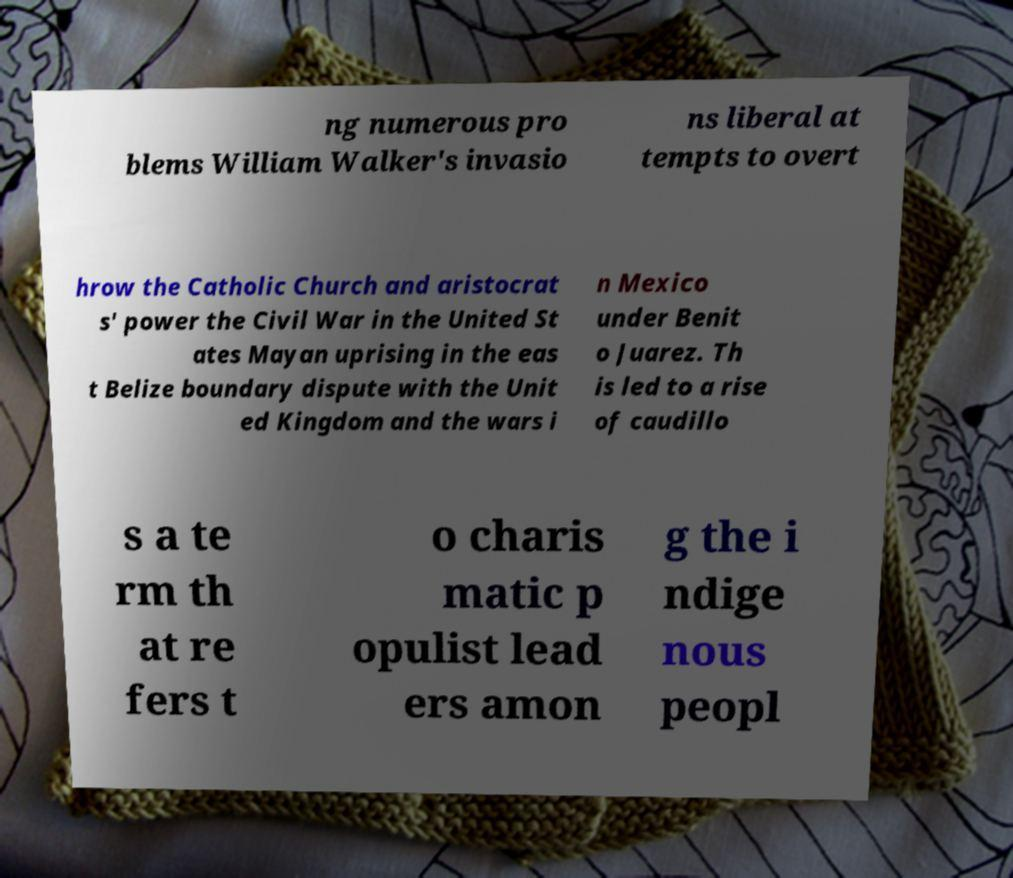I need the written content from this picture converted into text. Can you do that? ng numerous pro blems William Walker's invasio ns liberal at tempts to overt hrow the Catholic Church and aristocrat s' power the Civil War in the United St ates Mayan uprising in the eas t Belize boundary dispute with the Unit ed Kingdom and the wars i n Mexico under Benit o Juarez. Th is led to a rise of caudillo s a te rm th at re fers t o charis matic p opulist lead ers amon g the i ndige nous peopl 